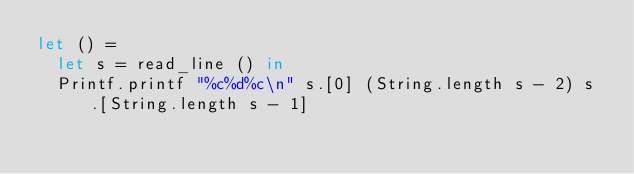<code> <loc_0><loc_0><loc_500><loc_500><_OCaml_>let () =
  let s = read_line () in
  Printf.printf "%c%d%c\n" s.[0] (String.length s - 2) s.[String.length s - 1]
</code> 